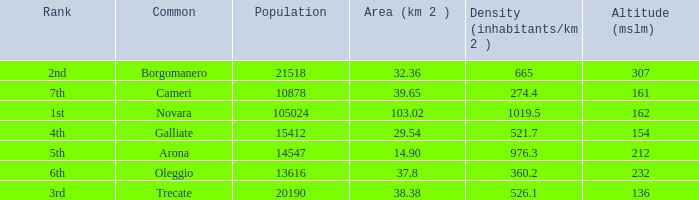Which common has an area (km2) of 103.02? Novara. 